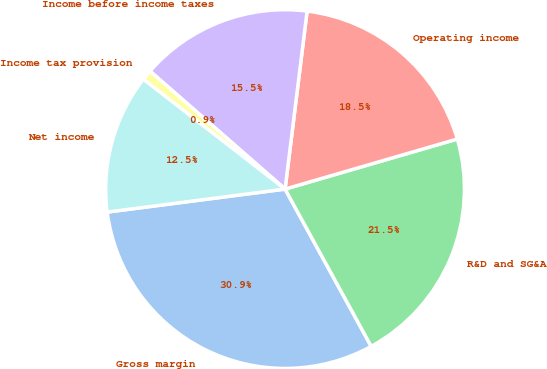Convert chart. <chart><loc_0><loc_0><loc_500><loc_500><pie_chart><fcel>Gross margin<fcel>R&D and SG&A<fcel>Operating income<fcel>Income before income taxes<fcel>Income tax provision<fcel>Net income<nl><fcel>30.93%<fcel>21.53%<fcel>18.54%<fcel>15.54%<fcel>0.93%<fcel>12.54%<nl></chart> 